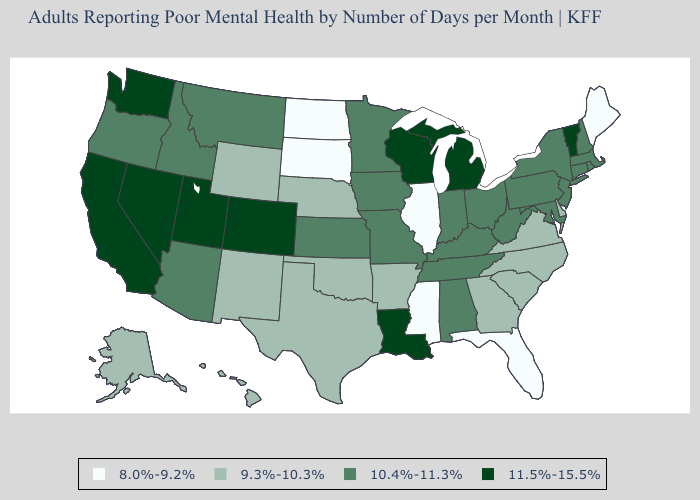How many symbols are there in the legend?
Keep it brief. 4. What is the highest value in states that border Tennessee?
Write a very short answer. 10.4%-11.3%. Which states have the lowest value in the MidWest?
Answer briefly. Illinois, North Dakota, South Dakota. Does Alabama have the same value as Tennessee?
Keep it brief. Yes. What is the lowest value in states that border Kansas?
Write a very short answer. 9.3%-10.3%. What is the lowest value in the South?
Write a very short answer. 8.0%-9.2%. Does Rhode Island have a higher value than Arkansas?
Short answer required. Yes. Does Pennsylvania have the lowest value in the Northeast?
Concise answer only. No. Which states have the lowest value in the West?
Answer briefly. Alaska, Hawaii, New Mexico, Wyoming. What is the value of Kansas?
Quick response, please. 10.4%-11.3%. Does Mississippi have the lowest value in the USA?
Give a very brief answer. Yes. Does South Dakota have the lowest value in the USA?
Be succinct. Yes. Name the states that have a value in the range 8.0%-9.2%?
Short answer required. Florida, Illinois, Maine, Mississippi, North Dakota, South Dakota. Name the states that have a value in the range 10.4%-11.3%?
Be succinct. Alabama, Arizona, Connecticut, Idaho, Indiana, Iowa, Kansas, Kentucky, Maryland, Massachusetts, Minnesota, Missouri, Montana, New Hampshire, New Jersey, New York, Ohio, Oregon, Pennsylvania, Rhode Island, Tennessee, West Virginia. Among the states that border Vermont , which have the lowest value?
Keep it brief. Massachusetts, New Hampshire, New York. 